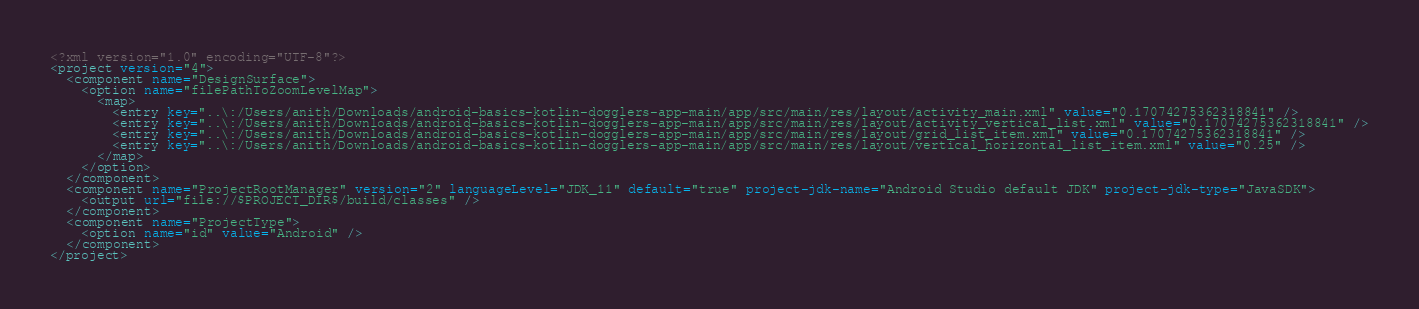<code> <loc_0><loc_0><loc_500><loc_500><_XML_><?xml version="1.0" encoding="UTF-8"?>
<project version="4">
  <component name="DesignSurface">
    <option name="filePathToZoomLevelMap">
      <map>
        <entry key="..\:/Users/anith/Downloads/android-basics-kotlin-dogglers-app-main/app/src/main/res/layout/activity_main.xml" value="0.17074275362318841" />
        <entry key="..\:/Users/anith/Downloads/android-basics-kotlin-dogglers-app-main/app/src/main/res/layout/activity_vertical_list.xml" value="0.17074275362318841" />
        <entry key="..\:/Users/anith/Downloads/android-basics-kotlin-dogglers-app-main/app/src/main/res/layout/grid_list_item.xml" value="0.17074275362318841" />
        <entry key="..\:/Users/anith/Downloads/android-basics-kotlin-dogglers-app-main/app/src/main/res/layout/vertical_horizontal_list_item.xml" value="0.25" />
      </map>
    </option>
  </component>
  <component name="ProjectRootManager" version="2" languageLevel="JDK_11" default="true" project-jdk-name="Android Studio default JDK" project-jdk-type="JavaSDK">
    <output url="file://$PROJECT_DIR$/build/classes" />
  </component>
  <component name="ProjectType">
    <option name="id" value="Android" />
  </component>
</project></code> 